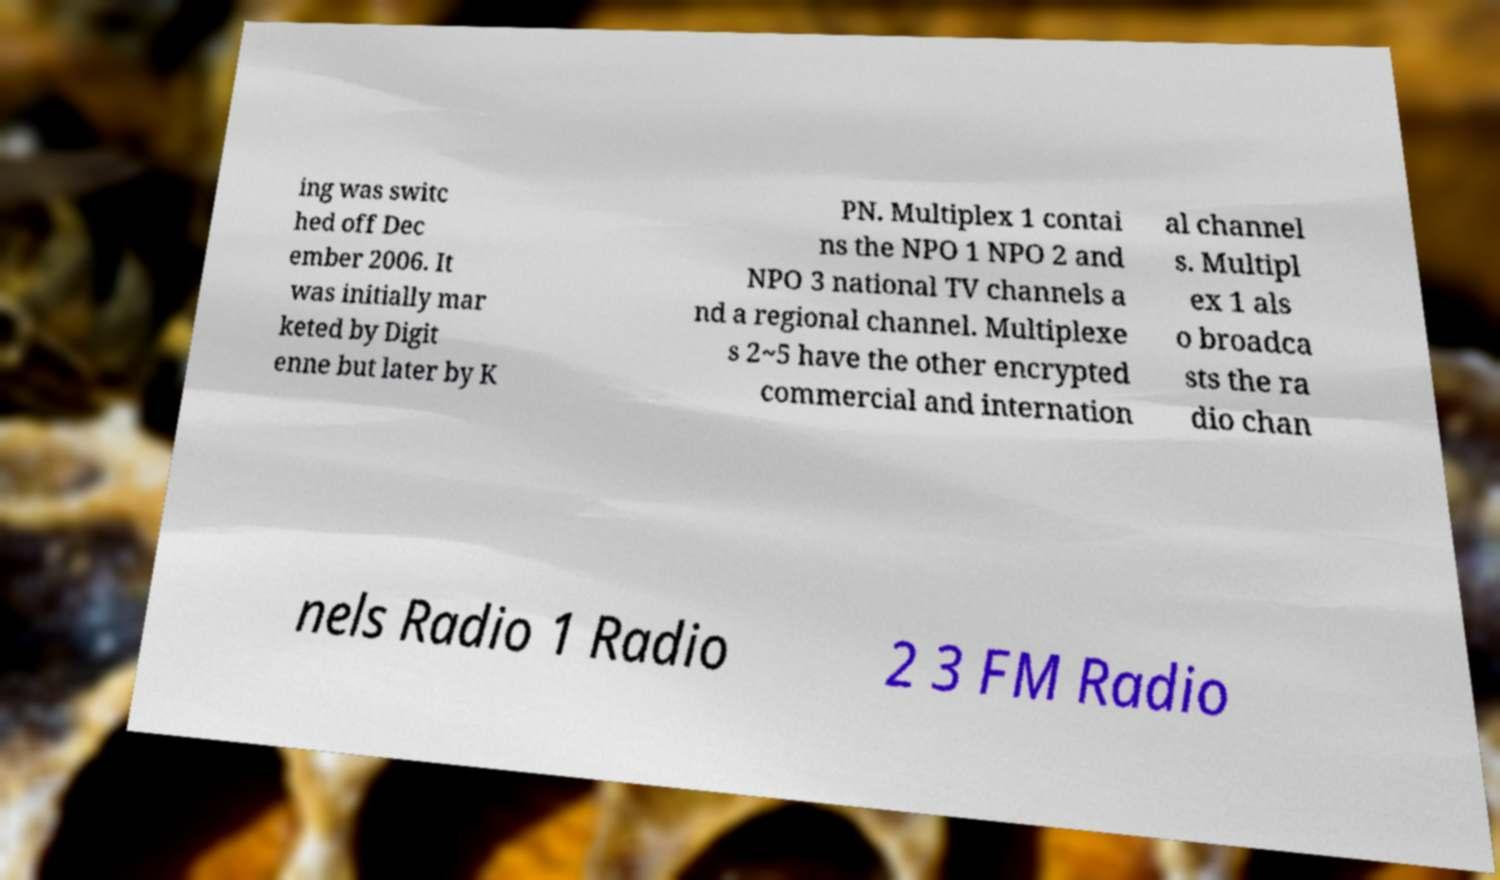Could you assist in decoding the text presented in this image and type it out clearly? ing was switc hed off Dec ember 2006. It was initially mar keted by Digit enne but later by K PN. Multiplex 1 contai ns the NPO 1 NPO 2 and NPO 3 national TV channels a nd a regional channel. Multiplexe s 2~5 have the other encrypted commercial and internation al channel s. Multipl ex 1 als o broadca sts the ra dio chan nels Radio 1 Radio 2 3 FM Radio 